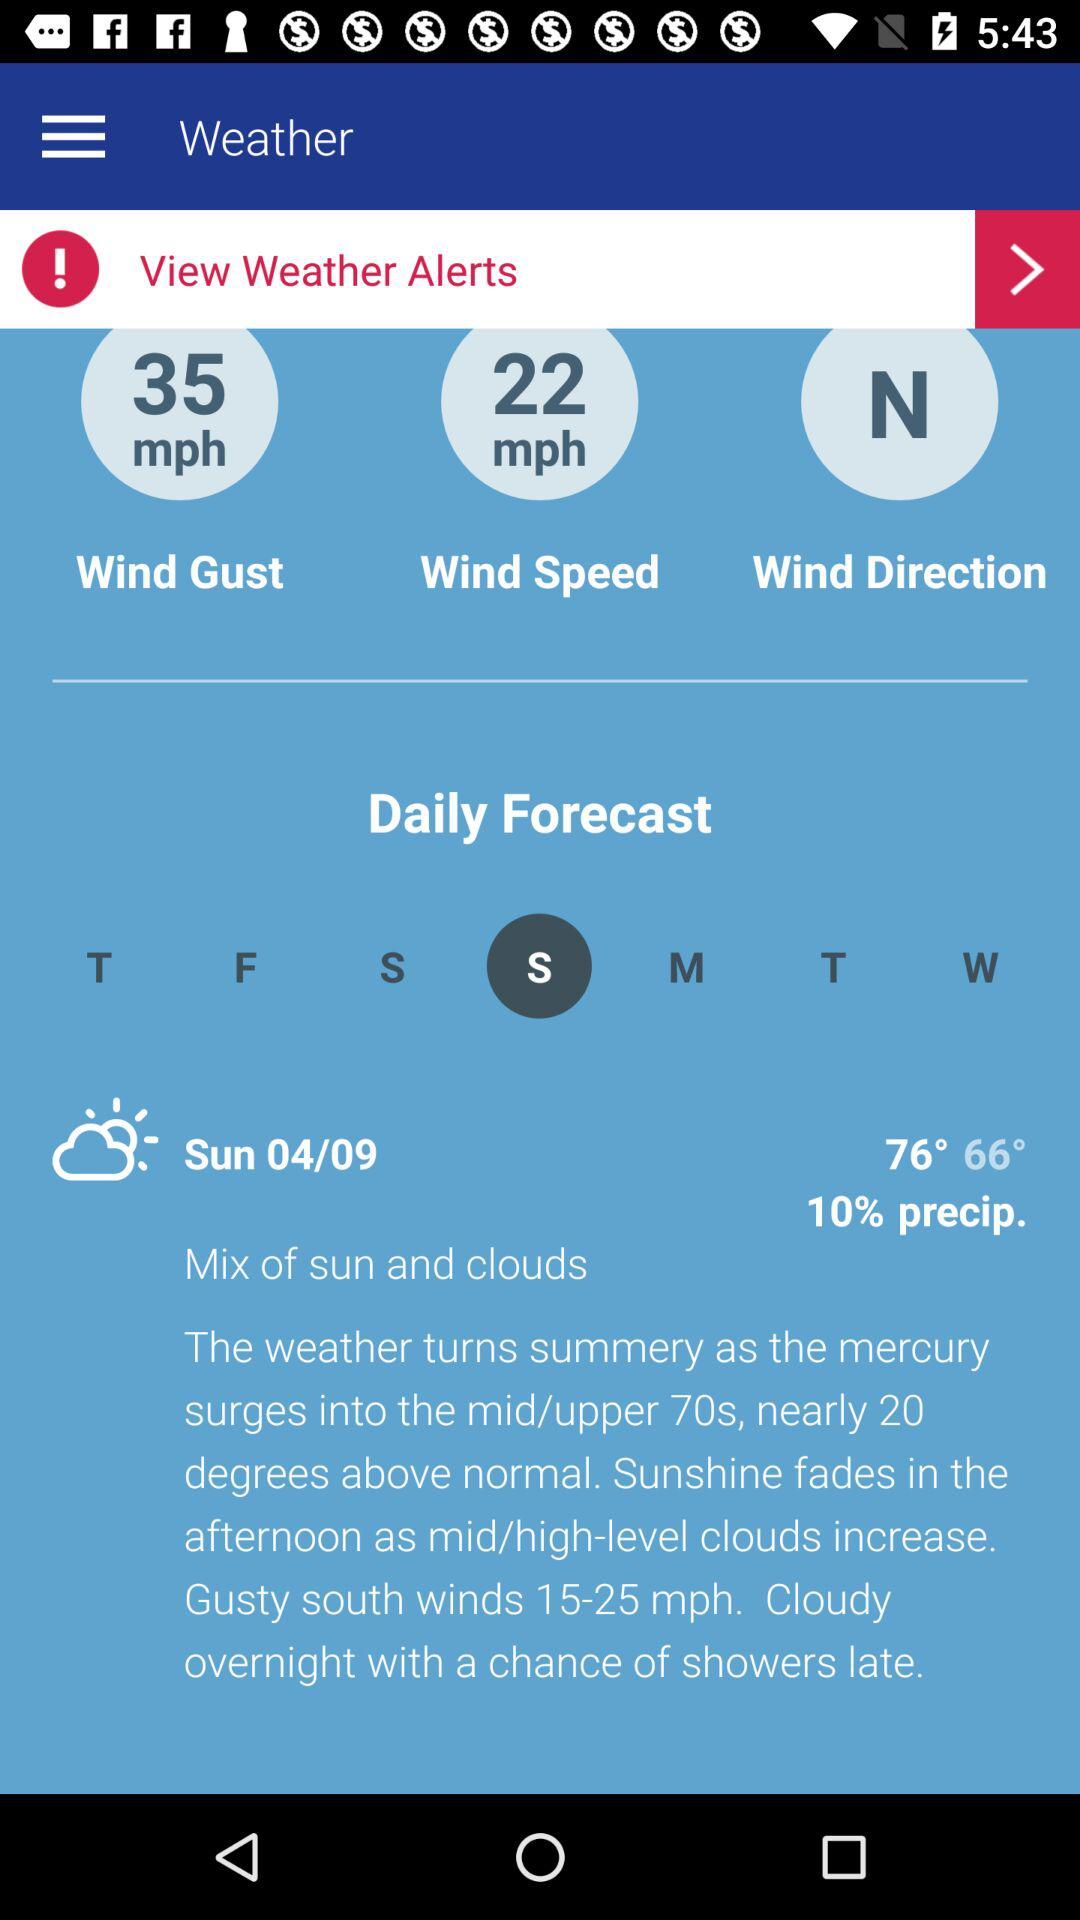Where is the wind direction? The wind direction is North. 